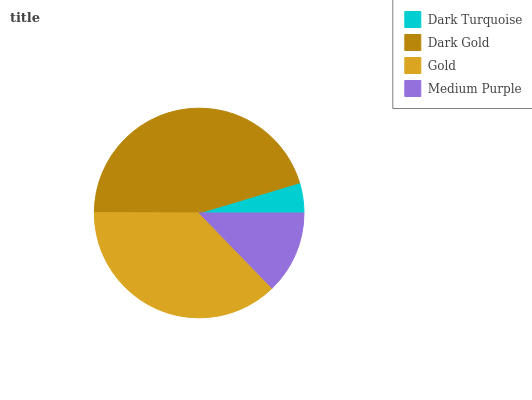Is Dark Turquoise the minimum?
Answer yes or no. Yes. Is Dark Gold the maximum?
Answer yes or no. Yes. Is Gold the minimum?
Answer yes or no. No. Is Gold the maximum?
Answer yes or no. No. Is Dark Gold greater than Gold?
Answer yes or no. Yes. Is Gold less than Dark Gold?
Answer yes or no. Yes. Is Gold greater than Dark Gold?
Answer yes or no. No. Is Dark Gold less than Gold?
Answer yes or no. No. Is Gold the high median?
Answer yes or no. Yes. Is Medium Purple the low median?
Answer yes or no. Yes. Is Dark Gold the high median?
Answer yes or no. No. Is Gold the low median?
Answer yes or no. No. 